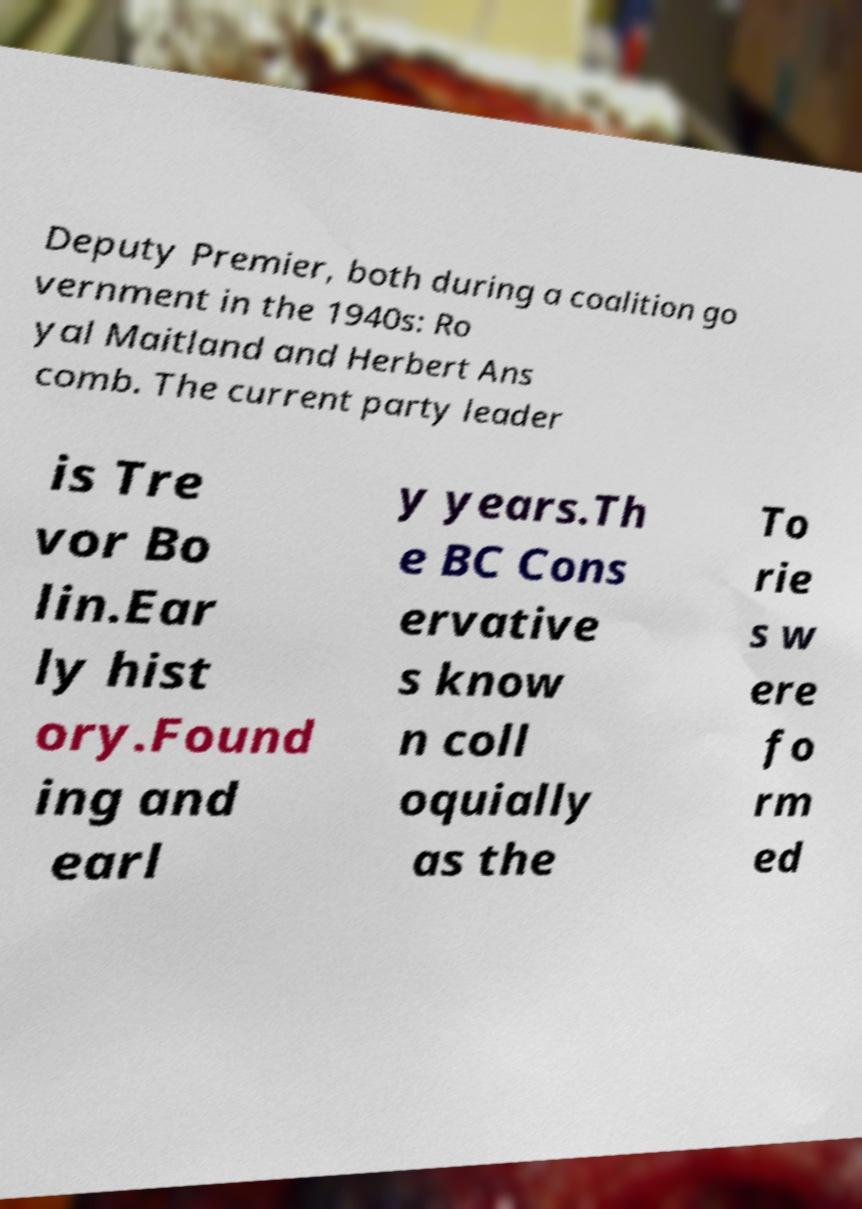Could you extract and type out the text from this image? Deputy Premier, both during a coalition go vernment in the 1940s: Ro yal Maitland and Herbert Ans comb. The current party leader is Tre vor Bo lin.Ear ly hist ory.Found ing and earl y years.Th e BC Cons ervative s know n coll oquially as the To rie s w ere fo rm ed 